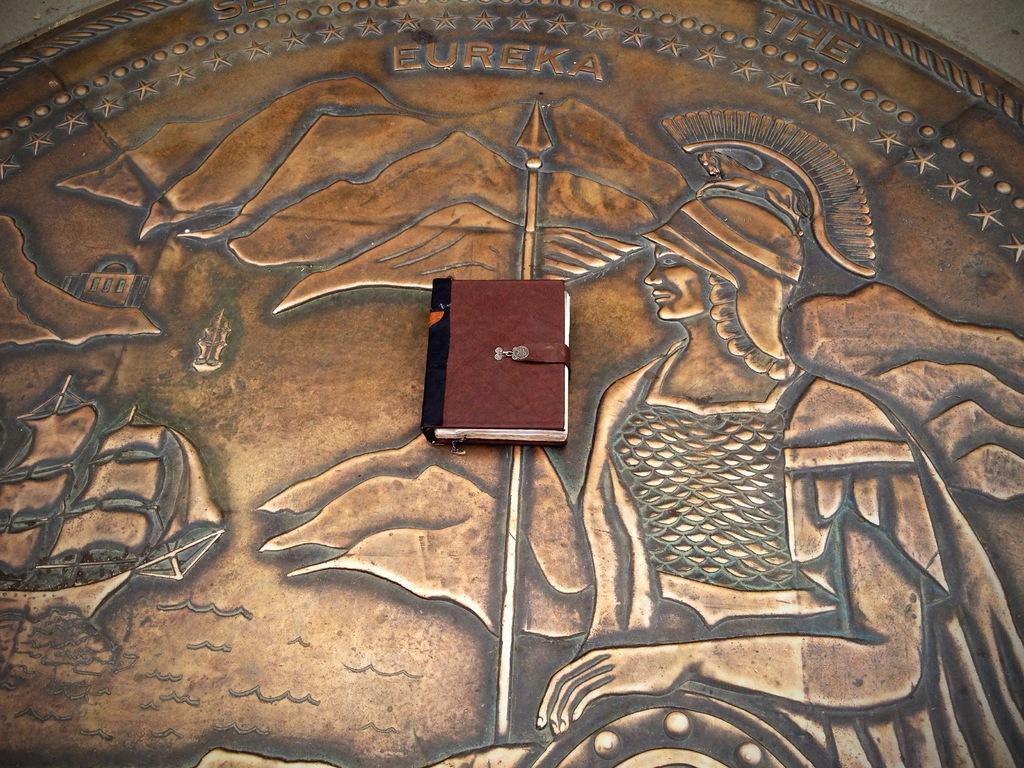How would you summarize this image in a sentence or two? In this image I can see the wall and on the wall I can see a metal sheet which is brown and black in color. On the sheet I can see the shape of a person holding a weapon. On the sheet I can see a book which is brown, black and white in color. 